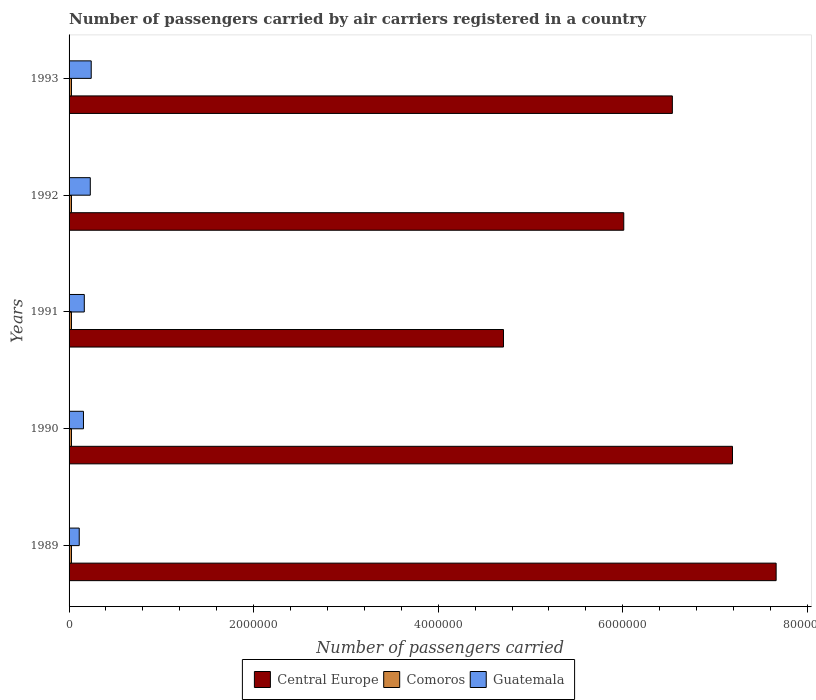How many different coloured bars are there?
Your response must be concise. 3. How many groups of bars are there?
Make the answer very short. 5. Are the number of bars per tick equal to the number of legend labels?
Your answer should be compact. Yes. What is the label of the 5th group of bars from the top?
Give a very brief answer. 1989. In how many cases, is the number of bars for a given year not equal to the number of legend labels?
Your answer should be compact. 0. What is the number of passengers carried by air carriers in Guatemala in 1990?
Your response must be concise. 1.56e+05. Across all years, what is the maximum number of passengers carried by air carriers in Central Europe?
Your answer should be compact. 7.66e+06. Across all years, what is the minimum number of passengers carried by air carriers in Guatemala?
Your answer should be compact. 1.10e+05. In which year was the number of passengers carried by air carriers in Comoros minimum?
Ensure brevity in your answer.  1989. What is the total number of passengers carried by air carriers in Comoros in the graph?
Make the answer very short. 1.30e+05. What is the difference between the number of passengers carried by air carriers in Guatemala in 1991 and the number of passengers carried by air carriers in Comoros in 1989?
Offer a very short reply. 1.39e+05. What is the average number of passengers carried by air carriers in Central Europe per year?
Your answer should be very brief. 6.42e+06. In the year 1990, what is the difference between the number of passengers carried by air carriers in Comoros and number of passengers carried by air carriers in Central Europe?
Your answer should be compact. -7.16e+06. In how many years, is the number of passengers carried by air carriers in Comoros greater than 7600000 ?
Make the answer very short. 0. What is the ratio of the number of passengers carried by air carriers in Guatemala in 1991 to that in 1992?
Your response must be concise. 0.72. Is the number of passengers carried by air carriers in Central Europe in 1989 less than that in 1993?
Provide a short and direct response. No. What is the difference between the highest and the lowest number of passengers carried by air carriers in Comoros?
Keep it short and to the point. 0. What does the 3rd bar from the top in 1990 represents?
Keep it short and to the point. Central Europe. What does the 1st bar from the bottom in 1993 represents?
Your answer should be compact. Central Europe. Is it the case that in every year, the sum of the number of passengers carried by air carriers in Guatemala and number of passengers carried by air carriers in Central Europe is greater than the number of passengers carried by air carriers in Comoros?
Your answer should be very brief. Yes. How many bars are there?
Provide a succinct answer. 15. What is the difference between two consecutive major ticks on the X-axis?
Your answer should be compact. 2.00e+06. Are the values on the major ticks of X-axis written in scientific E-notation?
Offer a terse response. No. Where does the legend appear in the graph?
Your answer should be compact. Bottom center. How many legend labels are there?
Keep it short and to the point. 3. What is the title of the graph?
Make the answer very short. Number of passengers carried by air carriers registered in a country. What is the label or title of the X-axis?
Give a very brief answer. Number of passengers carried. What is the label or title of the Y-axis?
Ensure brevity in your answer.  Years. What is the Number of passengers carried of Central Europe in 1989?
Your response must be concise. 7.66e+06. What is the Number of passengers carried of Comoros in 1989?
Your answer should be very brief. 2.60e+04. What is the Number of passengers carried of Guatemala in 1989?
Your response must be concise. 1.10e+05. What is the Number of passengers carried in Central Europe in 1990?
Give a very brief answer. 7.19e+06. What is the Number of passengers carried in Comoros in 1990?
Ensure brevity in your answer.  2.60e+04. What is the Number of passengers carried in Guatemala in 1990?
Offer a terse response. 1.56e+05. What is the Number of passengers carried of Central Europe in 1991?
Provide a succinct answer. 4.71e+06. What is the Number of passengers carried in Comoros in 1991?
Offer a very short reply. 2.60e+04. What is the Number of passengers carried in Guatemala in 1991?
Your answer should be compact. 1.65e+05. What is the Number of passengers carried in Central Europe in 1992?
Your answer should be very brief. 6.01e+06. What is the Number of passengers carried of Comoros in 1992?
Provide a succinct answer. 2.60e+04. What is the Number of passengers carried in Central Europe in 1993?
Give a very brief answer. 6.54e+06. What is the Number of passengers carried of Comoros in 1993?
Your answer should be very brief. 2.60e+04. What is the Number of passengers carried in Guatemala in 1993?
Make the answer very short. 2.40e+05. Across all years, what is the maximum Number of passengers carried of Central Europe?
Provide a succinct answer. 7.66e+06. Across all years, what is the maximum Number of passengers carried in Comoros?
Give a very brief answer. 2.60e+04. Across all years, what is the maximum Number of passengers carried in Guatemala?
Provide a succinct answer. 2.40e+05. Across all years, what is the minimum Number of passengers carried of Central Europe?
Provide a short and direct response. 4.71e+06. Across all years, what is the minimum Number of passengers carried in Comoros?
Offer a terse response. 2.60e+04. Across all years, what is the minimum Number of passengers carried of Guatemala?
Provide a succinct answer. 1.10e+05. What is the total Number of passengers carried in Central Europe in the graph?
Your answer should be very brief. 3.21e+07. What is the total Number of passengers carried of Guatemala in the graph?
Provide a succinct answer. 9.01e+05. What is the difference between the Number of passengers carried in Central Europe in 1989 and that in 1990?
Make the answer very short. 4.73e+05. What is the difference between the Number of passengers carried of Guatemala in 1989 and that in 1990?
Your answer should be very brief. -4.58e+04. What is the difference between the Number of passengers carried in Central Europe in 1989 and that in 1991?
Your response must be concise. 2.95e+06. What is the difference between the Number of passengers carried of Guatemala in 1989 and that in 1991?
Offer a terse response. -5.48e+04. What is the difference between the Number of passengers carried in Central Europe in 1989 and that in 1992?
Make the answer very short. 1.65e+06. What is the difference between the Number of passengers carried of Comoros in 1989 and that in 1992?
Provide a short and direct response. 0. What is the difference between the Number of passengers carried in Guatemala in 1989 and that in 1992?
Ensure brevity in your answer.  -1.20e+05. What is the difference between the Number of passengers carried in Central Europe in 1989 and that in 1993?
Keep it short and to the point. 1.12e+06. What is the difference between the Number of passengers carried in Guatemala in 1989 and that in 1993?
Make the answer very short. -1.30e+05. What is the difference between the Number of passengers carried in Central Europe in 1990 and that in 1991?
Keep it short and to the point. 2.48e+06. What is the difference between the Number of passengers carried of Guatemala in 1990 and that in 1991?
Provide a short and direct response. -9000. What is the difference between the Number of passengers carried in Central Europe in 1990 and that in 1992?
Make the answer very short. 1.18e+06. What is the difference between the Number of passengers carried in Comoros in 1990 and that in 1992?
Offer a terse response. 0. What is the difference between the Number of passengers carried of Guatemala in 1990 and that in 1992?
Provide a succinct answer. -7.40e+04. What is the difference between the Number of passengers carried of Central Europe in 1990 and that in 1993?
Offer a terse response. 6.52e+05. What is the difference between the Number of passengers carried of Comoros in 1990 and that in 1993?
Provide a succinct answer. 0. What is the difference between the Number of passengers carried in Guatemala in 1990 and that in 1993?
Your answer should be compact. -8.40e+04. What is the difference between the Number of passengers carried in Central Europe in 1991 and that in 1992?
Keep it short and to the point. -1.30e+06. What is the difference between the Number of passengers carried of Guatemala in 1991 and that in 1992?
Your answer should be very brief. -6.50e+04. What is the difference between the Number of passengers carried in Central Europe in 1991 and that in 1993?
Ensure brevity in your answer.  -1.83e+06. What is the difference between the Number of passengers carried of Comoros in 1991 and that in 1993?
Your answer should be compact. 0. What is the difference between the Number of passengers carried in Guatemala in 1991 and that in 1993?
Provide a short and direct response. -7.50e+04. What is the difference between the Number of passengers carried in Central Europe in 1992 and that in 1993?
Your answer should be compact. -5.27e+05. What is the difference between the Number of passengers carried of Guatemala in 1992 and that in 1993?
Offer a terse response. -10000. What is the difference between the Number of passengers carried of Central Europe in 1989 and the Number of passengers carried of Comoros in 1990?
Give a very brief answer. 7.64e+06. What is the difference between the Number of passengers carried of Central Europe in 1989 and the Number of passengers carried of Guatemala in 1990?
Keep it short and to the point. 7.51e+06. What is the difference between the Number of passengers carried of Comoros in 1989 and the Number of passengers carried of Guatemala in 1990?
Offer a very short reply. -1.30e+05. What is the difference between the Number of passengers carried in Central Europe in 1989 and the Number of passengers carried in Comoros in 1991?
Provide a short and direct response. 7.64e+06. What is the difference between the Number of passengers carried of Central Europe in 1989 and the Number of passengers carried of Guatemala in 1991?
Offer a terse response. 7.50e+06. What is the difference between the Number of passengers carried of Comoros in 1989 and the Number of passengers carried of Guatemala in 1991?
Your response must be concise. -1.39e+05. What is the difference between the Number of passengers carried of Central Europe in 1989 and the Number of passengers carried of Comoros in 1992?
Offer a very short reply. 7.64e+06. What is the difference between the Number of passengers carried of Central Europe in 1989 and the Number of passengers carried of Guatemala in 1992?
Your response must be concise. 7.43e+06. What is the difference between the Number of passengers carried of Comoros in 1989 and the Number of passengers carried of Guatemala in 1992?
Keep it short and to the point. -2.04e+05. What is the difference between the Number of passengers carried of Central Europe in 1989 and the Number of passengers carried of Comoros in 1993?
Your response must be concise. 7.64e+06. What is the difference between the Number of passengers carried in Central Europe in 1989 and the Number of passengers carried in Guatemala in 1993?
Your response must be concise. 7.42e+06. What is the difference between the Number of passengers carried in Comoros in 1989 and the Number of passengers carried in Guatemala in 1993?
Keep it short and to the point. -2.14e+05. What is the difference between the Number of passengers carried in Central Europe in 1990 and the Number of passengers carried in Comoros in 1991?
Your answer should be compact. 7.16e+06. What is the difference between the Number of passengers carried of Central Europe in 1990 and the Number of passengers carried of Guatemala in 1991?
Offer a very short reply. 7.02e+06. What is the difference between the Number of passengers carried of Comoros in 1990 and the Number of passengers carried of Guatemala in 1991?
Ensure brevity in your answer.  -1.39e+05. What is the difference between the Number of passengers carried of Central Europe in 1990 and the Number of passengers carried of Comoros in 1992?
Offer a terse response. 7.16e+06. What is the difference between the Number of passengers carried in Central Europe in 1990 and the Number of passengers carried in Guatemala in 1992?
Keep it short and to the point. 6.96e+06. What is the difference between the Number of passengers carried in Comoros in 1990 and the Number of passengers carried in Guatemala in 1992?
Provide a short and direct response. -2.04e+05. What is the difference between the Number of passengers carried in Central Europe in 1990 and the Number of passengers carried in Comoros in 1993?
Provide a short and direct response. 7.16e+06. What is the difference between the Number of passengers carried of Central Europe in 1990 and the Number of passengers carried of Guatemala in 1993?
Give a very brief answer. 6.95e+06. What is the difference between the Number of passengers carried of Comoros in 1990 and the Number of passengers carried of Guatemala in 1993?
Offer a terse response. -2.14e+05. What is the difference between the Number of passengers carried in Central Europe in 1991 and the Number of passengers carried in Comoros in 1992?
Offer a very short reply. 4.68e+06. What is the difference between the Number of passengers carried in Central Europe in 1991 and the Number of passengers carried in Guatemala in 1992?
Provide a succinct answer. 4.48e+06. What is the difference between the Number of passengers carried in Comoros in 1991 and the Number of passengers carried in Guatemala in 1992?
Provide a succinct answer. -2.04e+05. What is the difference between the Number of passengers carried of Central Europe in 1991 and the Number of passengers carried of Comoros in 1993?
Give a very brief answer. 4.68e+06. What is the difference between the Number of passengers carried of Central Europe in 1991 and the Number of passengers carried of Guatemala in 1993?
Provide a succinct answer. 4.47e+06. What is the difference between the Number of passengers carried in Comoros in 1991 and the Number of passengers carried in Guatemala in 1993?
Provide a succinct answer. -2.14e+05. What is the difference between the Number of passengers carried in Central Europe in 1992 and the Number of passengers carried in Comoros in 1993?
Provide a succinct answer. 5.98e+06. What is the difference between the Number of passengers carried of Central Europe in 1992 and the Number of passengers carried of Guatemala in 1993?
Provide a short and direct response. 5.77e+06. What is the difference between the Number of passengers carried of Comoros in 1992 and the Number of passengers carried of Guatemala in 1993?
Your answer should be compact. -2.14e+05. What is the average Number of passengers carried in Central Europe per year?
Provide a succinct answer. 6.42e+06. What is the average Number of passengers carried of Comoros per year?
Ensure brevity in your answer.  2.60e+04. What is the average Number of passengers carried in Guatemala per year?
Make the answer very short. 1.80e+05. In the year 1989, what is the difference between the Number of passengers carried of Central Europe and Number of passengers carried of Comoros?
Your response must be concise. 7.64e+06. In the year 1989, what is the difference between the Number of passengers carried of Central Europe and Number of passengers carried of Guatemala?
Your answer should be very brief. 7.55e+06. In the year 1989, what is the difference between the Number of passengers carried in Comoros and Number of passengers carried in Guatemala?
Provide a short and direct response. -8.42e+04. In the year 1990, what is the difference between the Number of passengers carried of Central Europe and Number of passengers carried of Comoros?
Keep it short and to the point. 7.16e+06. In the year 1990, what is the difference between the Number of passengers carried in Central Europe and Number of passengers carried in Guatemala?
Your response must be concise. 7.03e+06. In the year 1991, what is the difference between the Number of passengers carried of Central Europe and Number of passengers carried of Comoros?
Provide a short and direct response. 4.68e+06. In the year 1991, what is the difference between the Number of passengers carried of Central Europe and Number of passengers carried of Guatemala?
Offer a terse response. 4.54e+06. In the year 1991, what is the difference between the Number of passengers carried in Comoros and Number of passengers carried in Guatemala?
Provide a succinct answer. -1.39e+05. In the year 1992, what is the difference between the Number of passengers carried of Central Europe and Number of passengers carried of Comoros?
Provide a succinct answer. 5.98e+06. In the year 1992, what is the difference between the Number of passengers carried in Central Europe and Number of passengers carried in Guatemala?
Offer a terse response. 5.78e+06. In the year 1992, what is the difference between the Number of passengers carried of Comoros and Number of passengers carried of Guatemala?
Provide a short and direct response. -2.04e+05. In the year 1993, what is the difference between the Number of passengers carried in Central Europe and Number of passengers carried in Comoros?
Offer a terse response. 6.51e+06. In the year 1993, what is the difference between the Number of passengers carried of Central Europe and Number of passengers carried of Guatemala?
Your response must be concise. 6.30e+06. In the year 1993, what is the difference between the Number of passengers carried of Comoros and Number of passengers carried of Guatemala?
Ensure brevity in your answer.  -2.14e+05. What is the ratio of the Number of passengers carried in Central Europe in 1989 to that in 1990?
Make the answer very short. 1.07. What is the ratio of the Number of passengers carried in Comoros in 1989 to that in 1990?
Ensure brevity in your answer.  1. What is the ratio of the Number of passengers carried of Guatemala in 1989 to that in 1990?
Keep it short and to the point. 0.71. What is the ratio of the Number of passengers carried in Central Europe in 1989 to that in 1991?
Offer a very short reply. 1.63. What is the ratio of the Number of passengers carried of Guatemala in 1989 to that in 1991?
Ensure brevity in your answer.  0.67. What is the ratio of the Number of passengers carried of Central Europe in 1989 to that in 1992?
Keep it short and to the point. 1.27. What is the ratio of the Number of passengers carried of Guatemala in 1989 to that in 1992?
Your answer should be compact. 0.48. What is the ratio of the Number of passengers carried in Central Europe in 1989 to that in 1993?
Your answer should be compact. 1.17. What is the ratio of the Number of passengers carried of Guatemala in 1989 to that in 1993?
Keep it short and to the point. 0.46. What is the ratio of the Number of passengers carried in Central Europe in 1990 to that in 1991?
Provide a succinct answer. 1.53. What is the ratio of the Number of passengers carried in Guatemala in 1990 to that in 1991?
Your response must be concise. 0.95. What is the ratio of the Number of passengers carried in Central Europe in 1990 to that in 1992?
Your answer should be very brief. 1.2. What is the ratio of the Number of passengers carried in Guatemala in 1990 to that in 1992?
Provide a short and direct response. 0.68. What is the ratio of the Number of passengers carried of Central Europe in 1990 to that in 1993?
Your answer should be very brief. 1.1. What is the ratio of the Number of passengers carried of Comoros in 1990 to that in 1993?
Your answer should be very brief. 1. What is the ratio of the Number of passengers carried in Guatemala in 1990 to that in 1993?
Provide a succinct answer. 0.65. What is the ratio of the Number of passengers carried of Central Europe in 1991 to that in 1992?
Offer a terse response. 0.78. What is the ratio of the Number of passengers carried of Comoros in 1991 to that in 1992?
Your response must be concise. 1. What is the ratio of the Number of passengers carried in Guatemala in 1991 to that in 1992?
Make the answer very short. 0.72. What is the ratio of the Number of passengers carried in Central Europe in 1991 to that in 1993?
Offer a terse response. 0.72. What is the ratio of the Number of passengers carried in Comoros in 1991 to that in 1993?
Offer a very short reply. 1. What is the ratio of the Number of passengers carried of Guatemala in 1991 to that in 1993?
Your answer should be very brief. 0.69. What is the ratio of the Number of passengers carried in Central Europe in 1992 to that in 1993?
Provide a short and direct response. 0.92. What is the difference between the highest and the second highest Number of passengers carried in Central Europe?
Your response must be concise. 4.73e+05. What is the difference between the highest and the second highest Number of passengers carried of Comoros?
Make the answer very short. 0. What is the difference between the highest and the lowest Number of passengers carried in Central Europe?
Keep it short and to the point. 2.95e+06. What is the difference between the highest and the lowest Number of passengers carried in Guatemala?
Your response must be concise. 1.30e+05. 